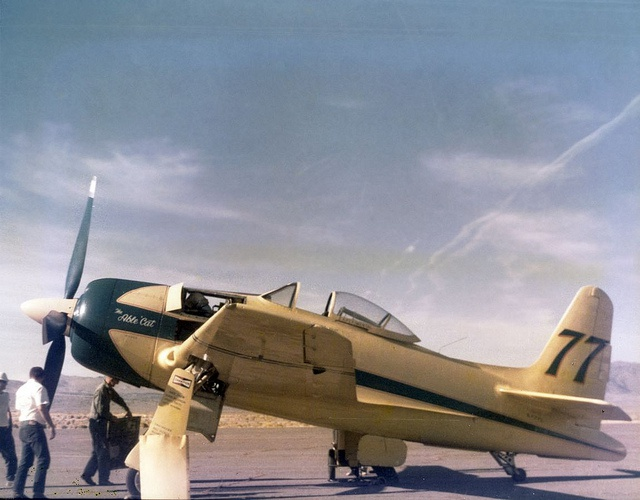Describe the objects in this image and their specific colors. I can see airplane in gray, maroon, and black tones, people in gray, white, navy, and darkgray tones, people in gray, black, and darkgray tones, people in gray, navy, and darkgray tones, and people in gray and black tones in this image. 